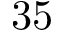Convert formula to latex. <formula><loc_0><loc_0><loc_500><loc_500>3 5</formula> 